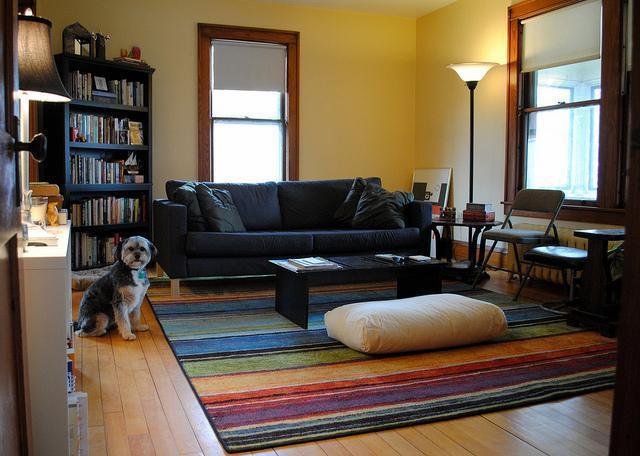How many pillows on the couch?
Give a very brief answer. 4. How many people visible are not in the stands?
Give a very brief answer. 0. 